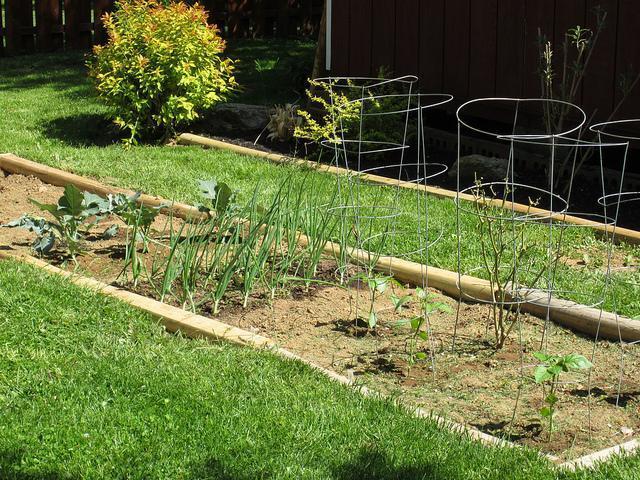How many people wearing glasses?
Give a very brief answer. 0. 